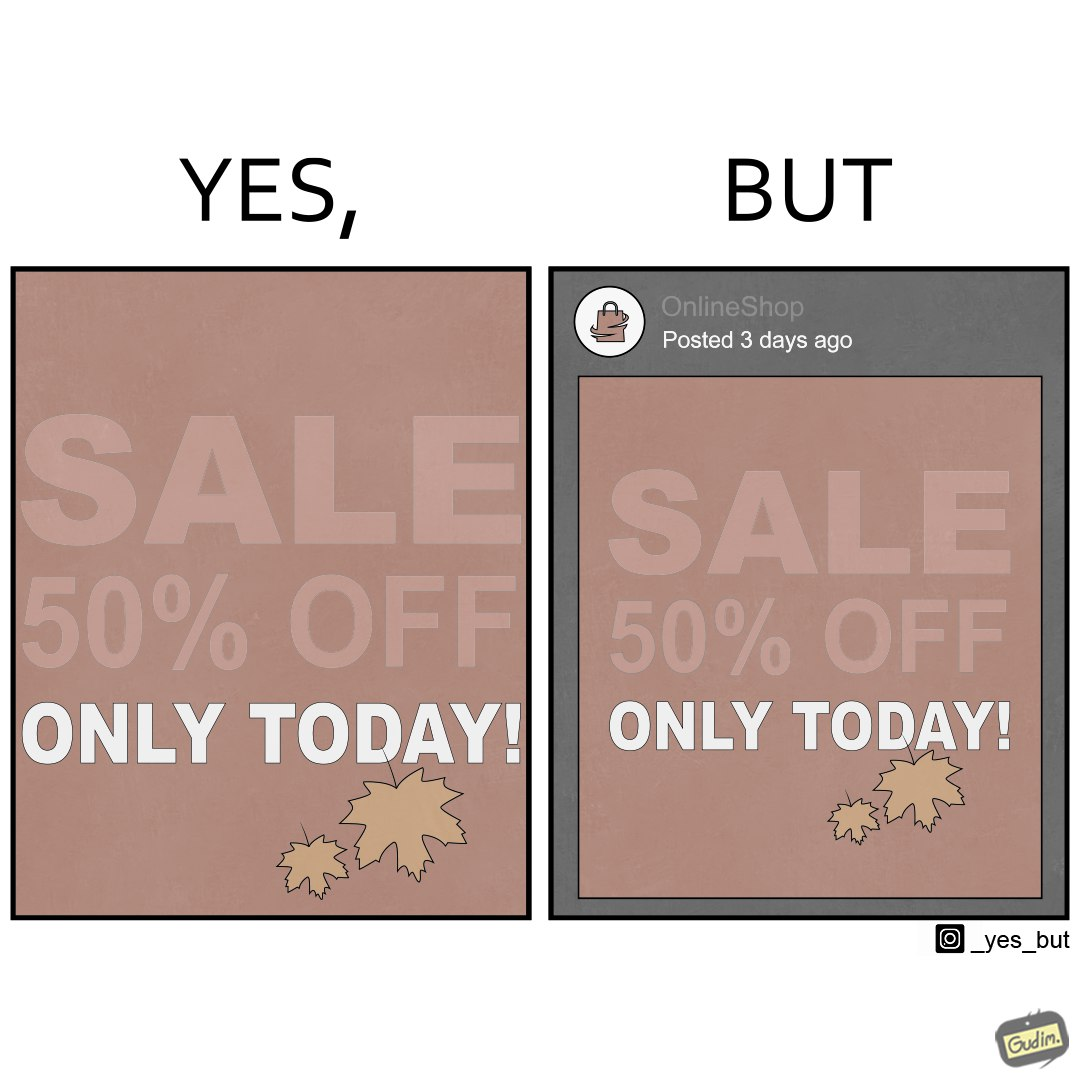Is this image satirical or non-satirical? Yes, this image is satirical. 